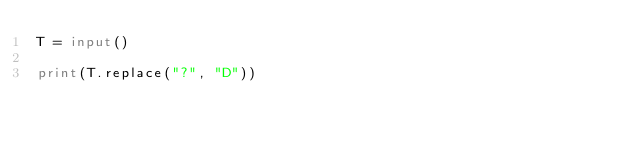<code> <loc_0><loc_0><loc_500><loc_500><_Python_>T = input()

print(T.replace("?", "D"))
</code> 